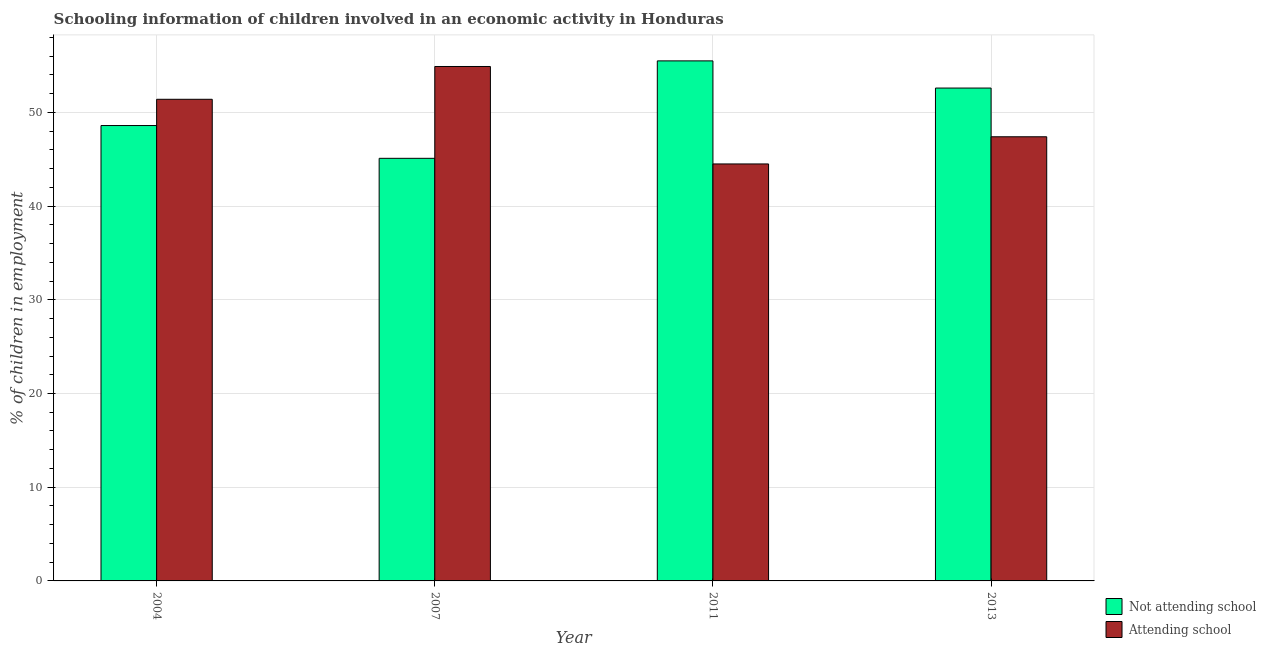How many groups of bars are there?
Give a very brief answer. 4. Are the number of bars per tick equal to the number of legend labels?
Provide a succinct answer. Yes. Are the number of bars on each tick of the X-axis equal?
Keep it short and to the point. Yes. How many bars are there on the 3rd tick from the right?
Keep it short and to the point. 2. In how many cases, is the number of bars for a given year not equal to the number of legend labels?
Keep it short and to the point. 0. What is the percentage of employed children who are attending school in 2007?
Provide a short and direct response. 54.9. Across all years, what is the maximum percentage of employed children who are attending school?
Provide a succinct answer. 54.9. Across all years, what is the minimum percentage of employed children who are not attending school?
Provide a short and direct response. 45.1. What is the total percentage of employed children who are not attending school in the graph?
Provide a succinct answer. 201.8. What is the difference between the percentage of employed children who are not attending school in 2007 and that in 2013?
Make the answer very short. -7.5. What is the difference between the percentage of employed children who are not attending school in 2011 and the percentage of employed children who are attending school in 2004?
Your answer should be very brief. 6.9. What is the average percentage of employed children who are not attending school per year?
Provide a succinct answer. 50.45. In how many years, is the percentage of employed children who are attending school greater than 28 %?
Give a very brief answer. 4. What is the ratio of the percentage of employed children who are not attending school in 2004 to that in 2011?
Offer a very short reply. 0.88. What is the difference between the highest and the second highest percentage of employed children who are not attending school?
Offer a terse response. 2.9. What is the difference between the highest and the lowest percentage of employed children who are attending school?
Your response must be concise. 10.4. What does the 1st bar from the left in 2007 represents?
Your answer should be compact. Not attending school. What does the 1st bar from the right in 2013 represents?
Ensure brevity in your answer.  Attending school. How many bars are there?
Your answer should be very brief. 8. Are the values on the major ticks of Y-axis written in scientific E-notation?
Offer a very short reply. No. Does the graph contain any zero values?
Make the answer very short. No. How many legend labels are there?
Offer a very short reply. 2. What is the title of the graph?
Your response must be concise. Schooling information of children involved in an economic activity in Honduras. What is the label or title of the X-axis?
Keep it short and to the point. Year. What is the label or title of the Y-axis?
Keep it short and to the point. % of children in employment. What is the % of children in employment of Not attending school in 2004?
Your answer should be compact. 48.6. What is the % of children in employment in Attending school in 2004?
Provide a succinct answer. 51.4. What is the % of children in employment of Not attending school in 2007?
Your response must be concise. 45.1. What is the % of children in employment in Attending school in 2007?
Provide a short and direct response. 54.9. What is the % of children in employment in Not attending school in 2011?
Ensure brevity in your answer.  55.5. What is the % of children in employment of Attending school in 2011?
Keep it short and to the point. 44.5. What is the % of children in employment of Not attending school in 2013?
Provide a succinct answer. 52.6. What is the % of children in employment in Attending school in 2013?
Make the answer very short. 47.4. Across all years, what is the maximum % of children in employment of Not attending school?
Provide a short and direct response. 55.5. Across all years, what is the maximum % of children in employment of Attending school?
Provide a short and direct response. 54.9. Across all years, what is the minimum % of children in employment in Not attending school?
Provide a short and direct response. 45.1. Across all years, what is the minimum % of children in employment in Attending school?
Provide a short and direct response. 44.5. What is the total % of children in employment in Not attending school in the graph?
Provide a short and direct response. 201.8. What is the total % of children in employment of Attending school in the graph?
Your response must be concise. 198.2. What is the difference between the % of children in employment of Not attending school in 2004 and that in 2007?
Provide a short and direct response. 3.5. What is the difference between the % of children in employment in Attending school in 2004 and that in 2007?
Your response must be concise. -3.5. What is the difference between the % of children in employment of Not attending school in 2004 and that in 2011?
Keep it short and to the point. -6.9. What is the difference between the % of children in employment of Attending school in 2004 and that in 2011?
Offer a very short reply. 6.9. What is the difference between the % of children in employment in Not attending school in 2007 and that in 2011?
Offer a terse response. -10.4. What is the difference between the % of children in employment in Not attending school in 2011 and that in 2013?
Your response must be concise. 2.9. What is the difference between the % of children in employment of Not attending school in 2004 and the % of children in employment of Attending school in 2011?
Make the answer very short. 4.1. What is the difference between the % of children in employment of Not attending school in 2007 and the % of children in employment of Attending school in 2013?
Offer a very short reply. -2.3. What is the difference between the % of children in employment in Not attending school in 2011 and the % of children in employment in Attending school in 2013?
Your response must be concise. 8.1. What is the average % of children in employment of Not attending school per year?
Offer a very short reply. 50.45. What is the average % of children in employment in Attending school per year?
Provide a succinct answer. 49.55. In the year 2007, what is the difference between the % of children in employment of Not attending school and % of children in employment of Attending school?
Provide a succinct answer. -9.8. In the year 2013, what is the difference between the % of children in employment in Not attending school and % of children in employment in Attending school?
Give a very brief answer. 5.2. What is the ratio of the % of children in employment of Not attending school in 2004 to that in 2007?
Provide a short and direct response. 1.08. What is the ratio of the % of children in employment of Attending school in 2004 to that in 2007?
Make the answer very short. 0.94. What is the ratio of the % of children in employment in Not attending school in 2004 to that in 2011?
Give a very brief answer. 0.88. What is the ratio of the % of children in employment of Attending school in 2004 to that in 2011?
Keep it short and to the point. 1.16. What is the ratio of the % of children in employment of Not attending school in 2004 to that in 2013?
Offer a very short reply. 0.92. What is the ratio of the % of children in employment of Attending school in 2004 to that in 2013?
Provide a succinct answer. 1.08. What is the ratio of the % of children in employment of Not attending school in 2007 to that in 2011?
Offer a terse response. 0.81. What is the ratio of the % of children in employment of Attending school in 2007 to that in 2011?
Provide a short and direct response. 1.23. What is the ratio of the % of children in employment of Not attending school in 2007 to that in 2013?
Offer a terse response. 0.86. What is the ratio of the % of children in employment in Attending school in 2007 to that in 2013?
Offer a terse response. 1.16. What is the ratio of the % of children in employment in Not attending school in 2011 to that in 2013?
Give a very brief answer. 1.06. What is the ratio of the % of children in employment of Attending school in 2011 to that in 2013?
Your answer should be very brief. 0.94. What is the difference between the highest and the second highest % of children in employment in Not attending school?
Your answer should be compact. 2.9. What is the difference between the highest and the second highest % of children in employment of Attending school?
Your response must be concise. 3.5. What is the difference between the highest and the lowest % of children in employment in Not attending school?
Ensure brevity in your answer.  10.4. What is the difference between the highest and the lowest % of children in employment of Attending school?
Give a very brief answer. 10.4. 